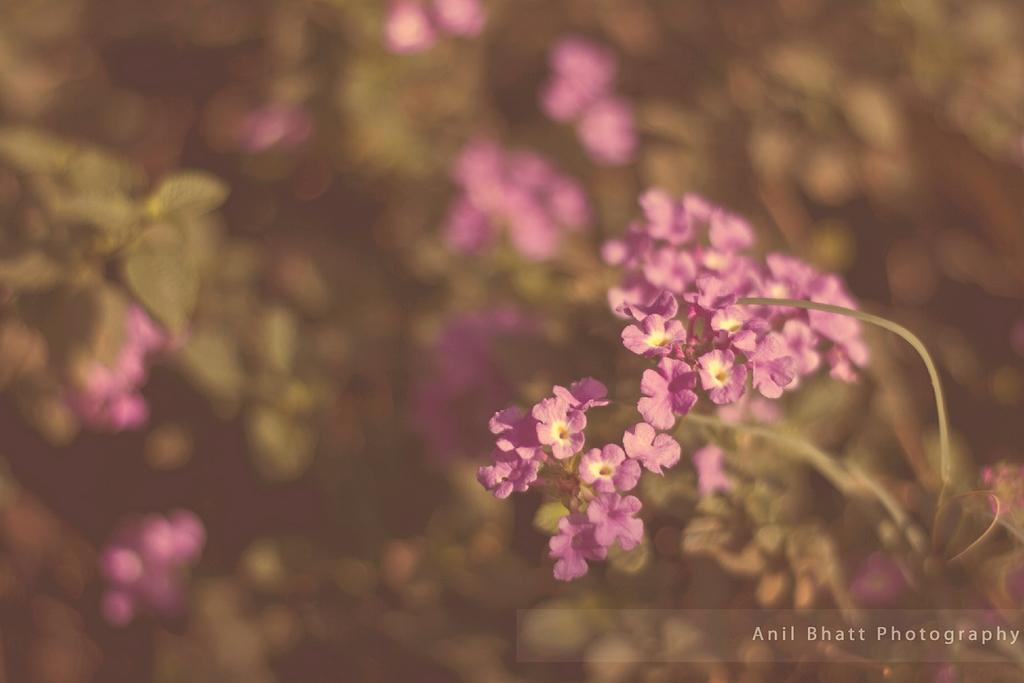What type of vegetation is visible in the front of the image? There are flowers in the front of the image. What type of vegetation is visible in the background of the image? There are leaves and flowers in the background of the image. Can you tell me how many forks are visible in the image? There are no forks present in the image. Is there a person in the image who is swimming? There is no person or swimming activity depicted in the image. 